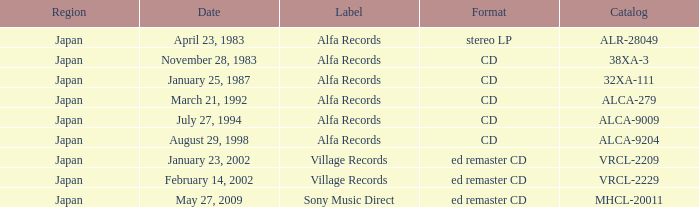On which date is the stereo long-playing record format? April 23, 1983. 